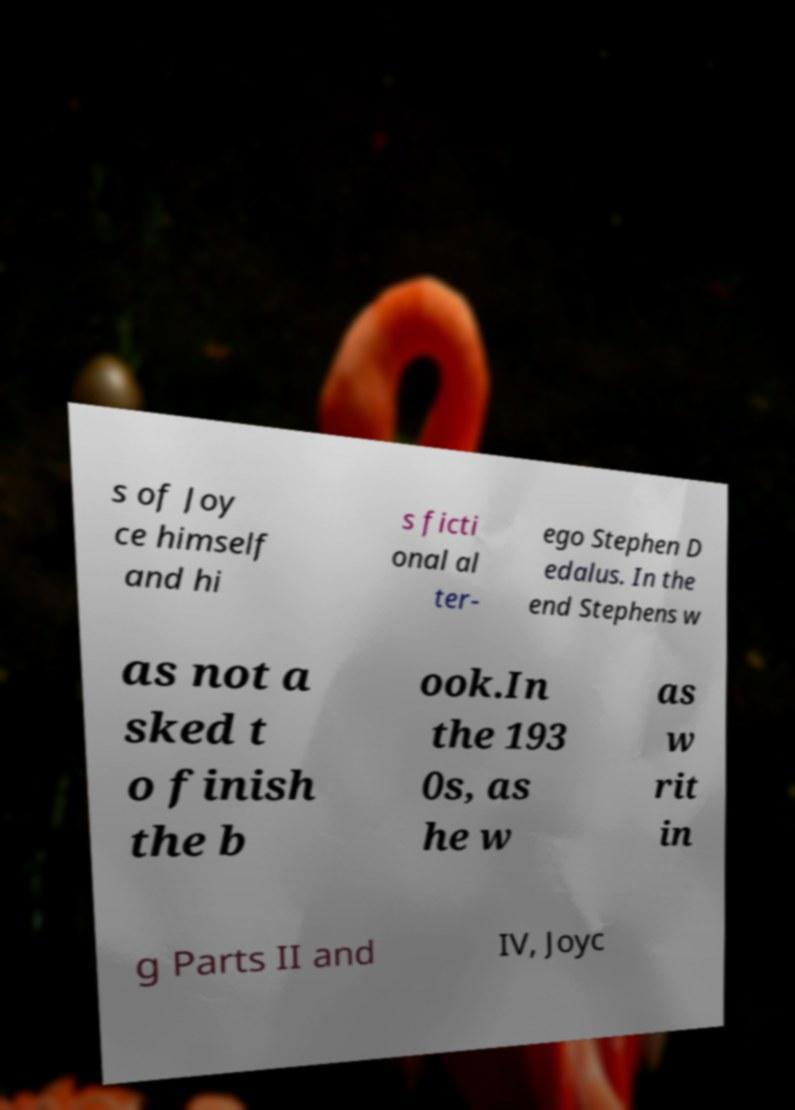Please read and relay the text visible in this image. What does it say? s of Joy ce himself and hi s ficti onal al ter- ego Stephen D edalus. In the end Stephens w as not a sked t o finish the b ook.In the 193 0s, as he w as w rit in g Parts II and IV, Joyc 